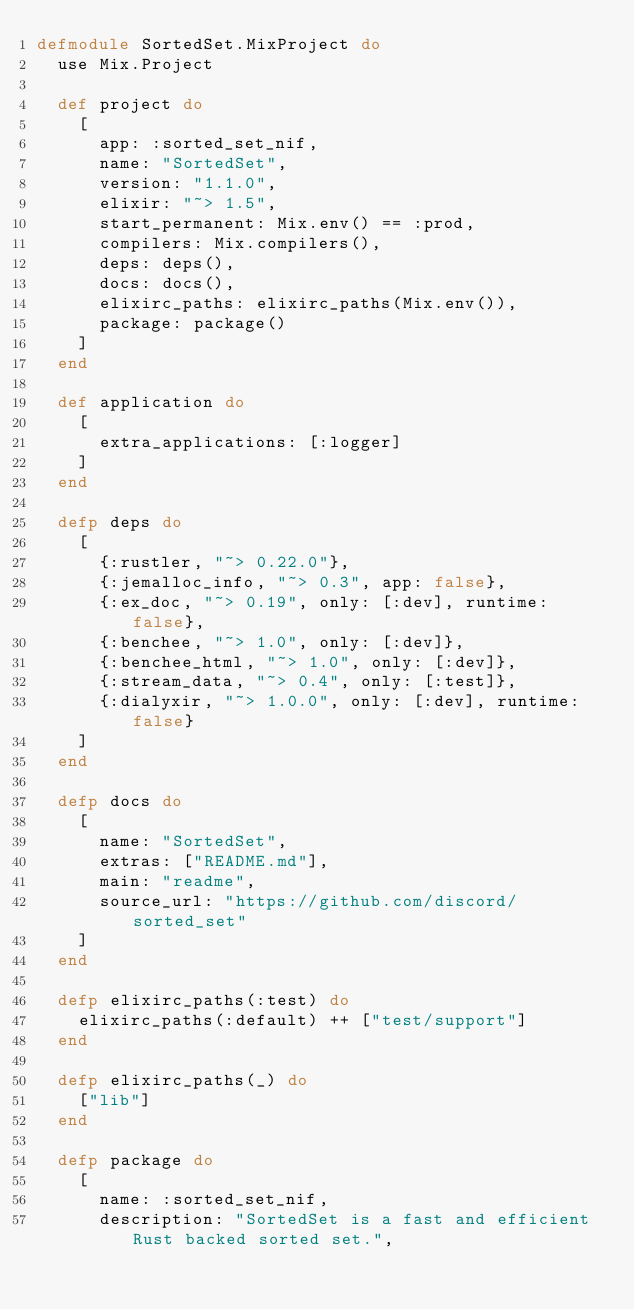<code> <loc_0><loc_0><loc_500><loc_500><_Elixir_>defmodule SortedSet.MixProject do
  use Mix.Project

  def project do
    [
      app: :sorted_set_nif,
      name: "SortedSet",
      version: "1.1.0",
      elixir: "~> 1.5",
      start_permanent: Mix.env() == :prod,
      compilers: Mix.compilers(),
      deps: deps(),
      docs: docs(),
      elixirc_paths: elixirc_paths(Mix.env()),
      package: package()
    ]
  end

  def application do
    [
      extra_applications: [:logger]
    ]
  end

  defp deps do
    [
      {:rustler, "~> 0.22.0"},
      {:jemalloc_info, "~> 0.3", app: false},
      {:ex_doc, "~> 0.19", only: [:dev], runtime: false},
      {:benchee, "~> 1.0", only: [:dev]},
      {:benchee_html, "~> 1.0", only: [:dev]},
      {:stream_data, "~> 0.4", only: [:test]},
      {:dialyxir, "~> 1.0.0", only: [:dev], runtime: false}
    ]
  end

  defp docs do
    [
      name: "SortedSet",
      extras: ["README.md"],
      main: "readme",
      source_url: "https://github.com/discord/sorted_set"
    ]
  end

  defp elixirc_paths(:test) do
    elixirc_paths(:default) ++ ["test/support"]
  end

  defp elixirc_paths(_) do
    ["lib"]
  end

  defp package do
    [
      name: :sorted_set_nif,
      description: "SortedSet is a fast and efficient Rust backed sorted set.",</code> 